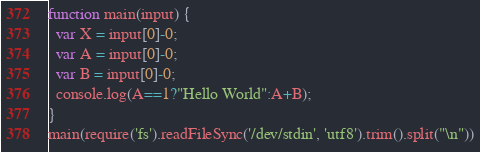Convert code to text. <code><loc_0><loc_0><loc_500><loc_500><_JavaScript_>function main(input) {
  var X = input[0]-0;
  var A = input[0]-0;
  var B = input[0]-0;
  console.log(A==1?"Hello World":A+B);
}
main(require('fs').readFileSync('/dev/stdin', 'utf8').trim().split("\n"))
</code> 